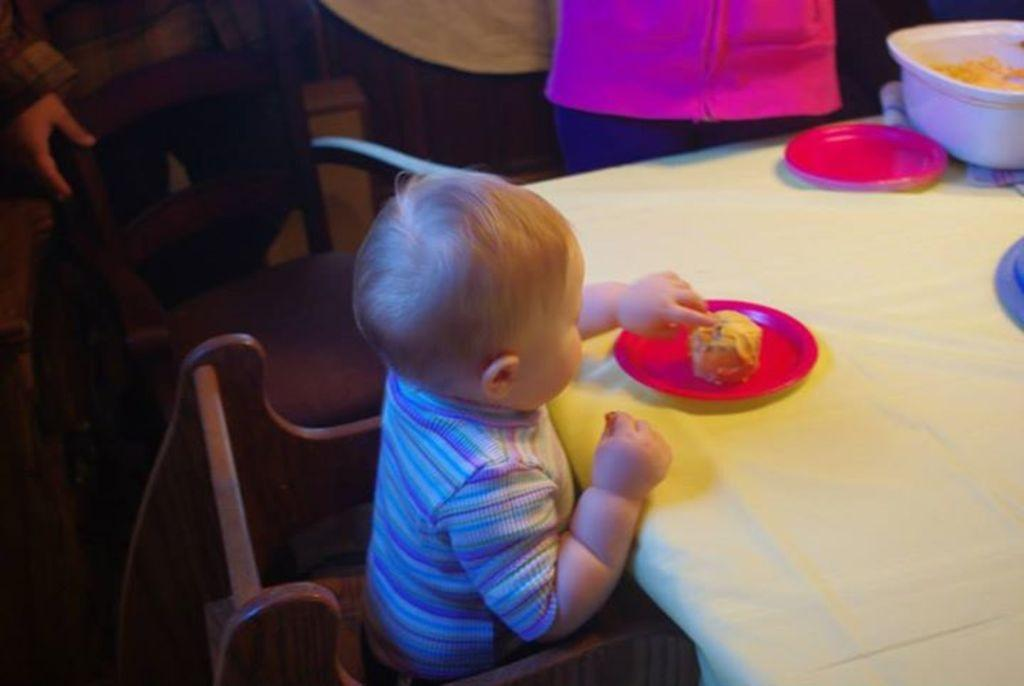What is the person in the image doing? The person is sitting on a chair in the image. What object is present in the image that is typically used for eating or working on? There is a table in the image. What items can be seen on the table? There is a plate and a bowl on the table. What arithmetic problem is the person solving on the table in the image? There is no arithmetic problem visible in the image; the person is simply sitting on a chair and there is a table with a plate and a bowl on it. 